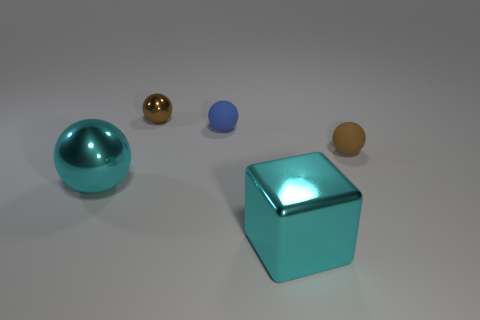Subtract all cyan shiny spheres. How many spheres are left? 3 Subtract all purple cubes. How many brown spheres are left? 2 Subtract all blue spheres. How many spheres are left? 3 Subtract all yellow spheres. Subtract all gray cubes. How many spheres are left? 4 Add 1 tiny green matte balls. How many objects exist? 6 Subtract all blocks. How many objects are left? 4 Subtract all brown metallic spheres. Subtract all rubber objects. How many objects are left? 2 Add 5 tiny brown shiny objects. How many tiny brown shiny objects are left? 6 Add 2 small brown rubber balls. How many small brown rubber balls exist? 3 Subtract 0 green spheres. How many objects are left? 5 